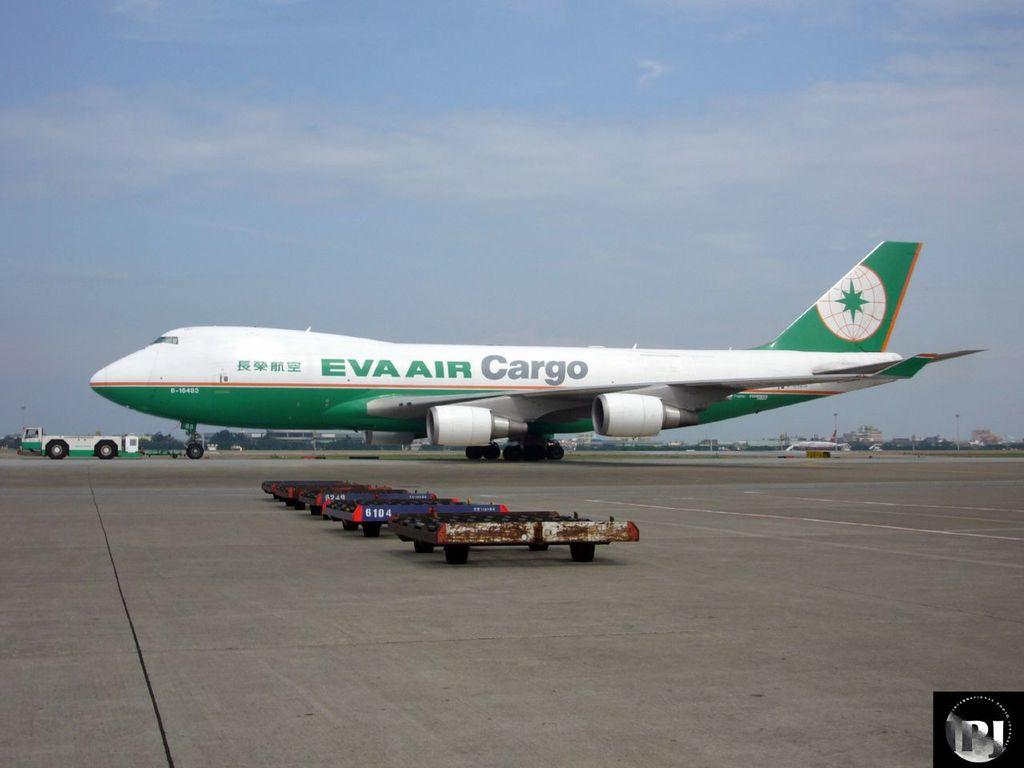<image>
Relay a brief, clear account of the picture shown. A cargo airplane from the company Eva Air 